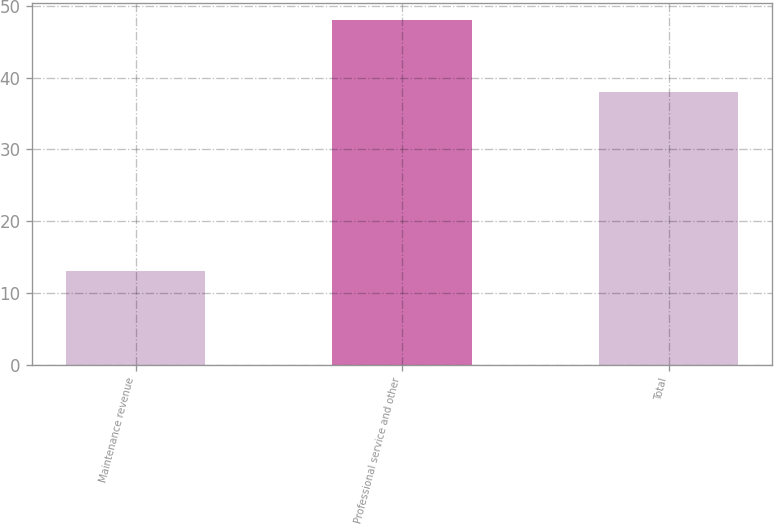Convert chart to OTSL. <chart><loc_0><loc_0><loc_500><loc_500><bar_chart><fcel>Maintenance revenue<fcel>Professional service and other<fcel>Total<nl><fcel>13<fcel>48<fcel>38<nl></chart> 